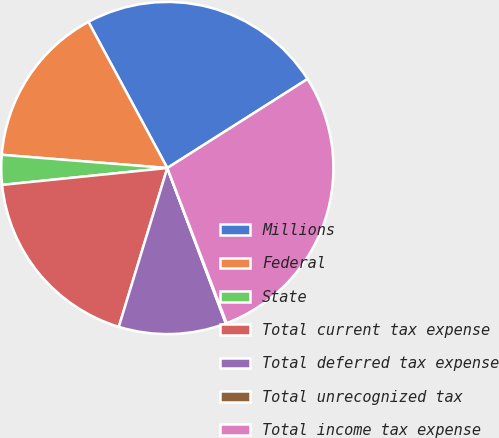Convert chart to OTSL. <chart><loc_0><loc_0><loc_500><loc_500><pie_chart><fcel>Millions<fcel>Federal<fcel>State<fcel>Total current tax expense<fcel>Total deferred tax expense<fcel>Total unrecognized tax<fcel>Total income tax expense<nl><fcel>23.88%<fcel>15.85%<fcel>2.89%<fcel>18.66%<fcel>10.45%<fcel>0.08%<fcel>28.19%<nl></chart> 